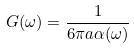<formula> <loc_0><loc_0><loc_500><loc_500>G ( \omega ) = \frac { 1 } { 6 \pi a \alpha ( \omega ) }</formula> 